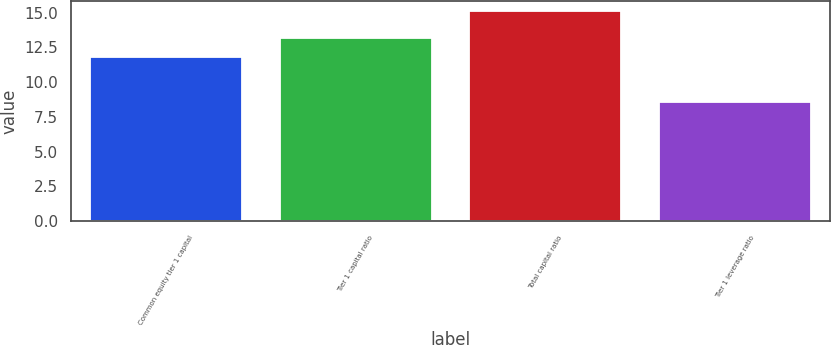Convert chart to OTSL. <chart><loc_0><loc_0><loc_500><loc_500><bar_chart><fcel>Common equity tier 1 capital<fcel>Tier 1 capital ratio<fcel>Total capital ratio<fcel>Tier 1 leverage ratio<nl><fcel>11.8<fcel>13.2<fcel>15.1<fcel>8.6<nl></chart> 